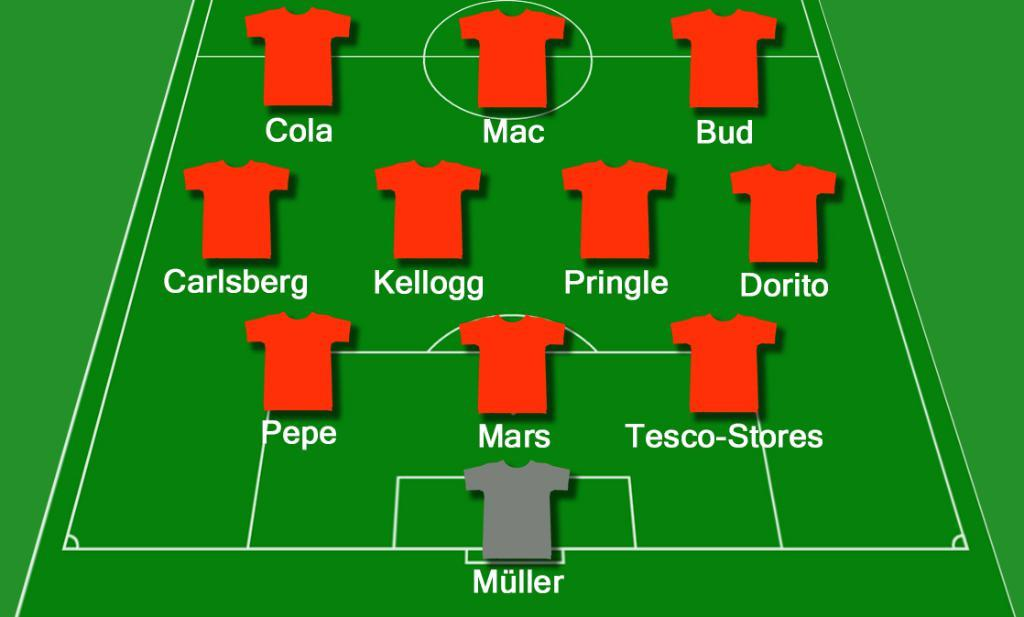<image>
Create a compact narrative representing the image presented. Several jerseys are laid out on a field, labelled for each player including Cola, Mac, and Bud. 